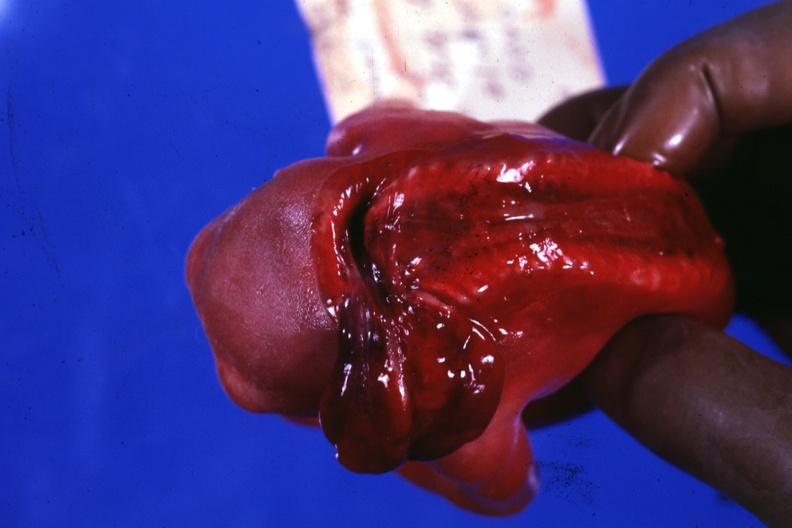s anencephaly present?
Answer the question using a single word or phrase. Yes 